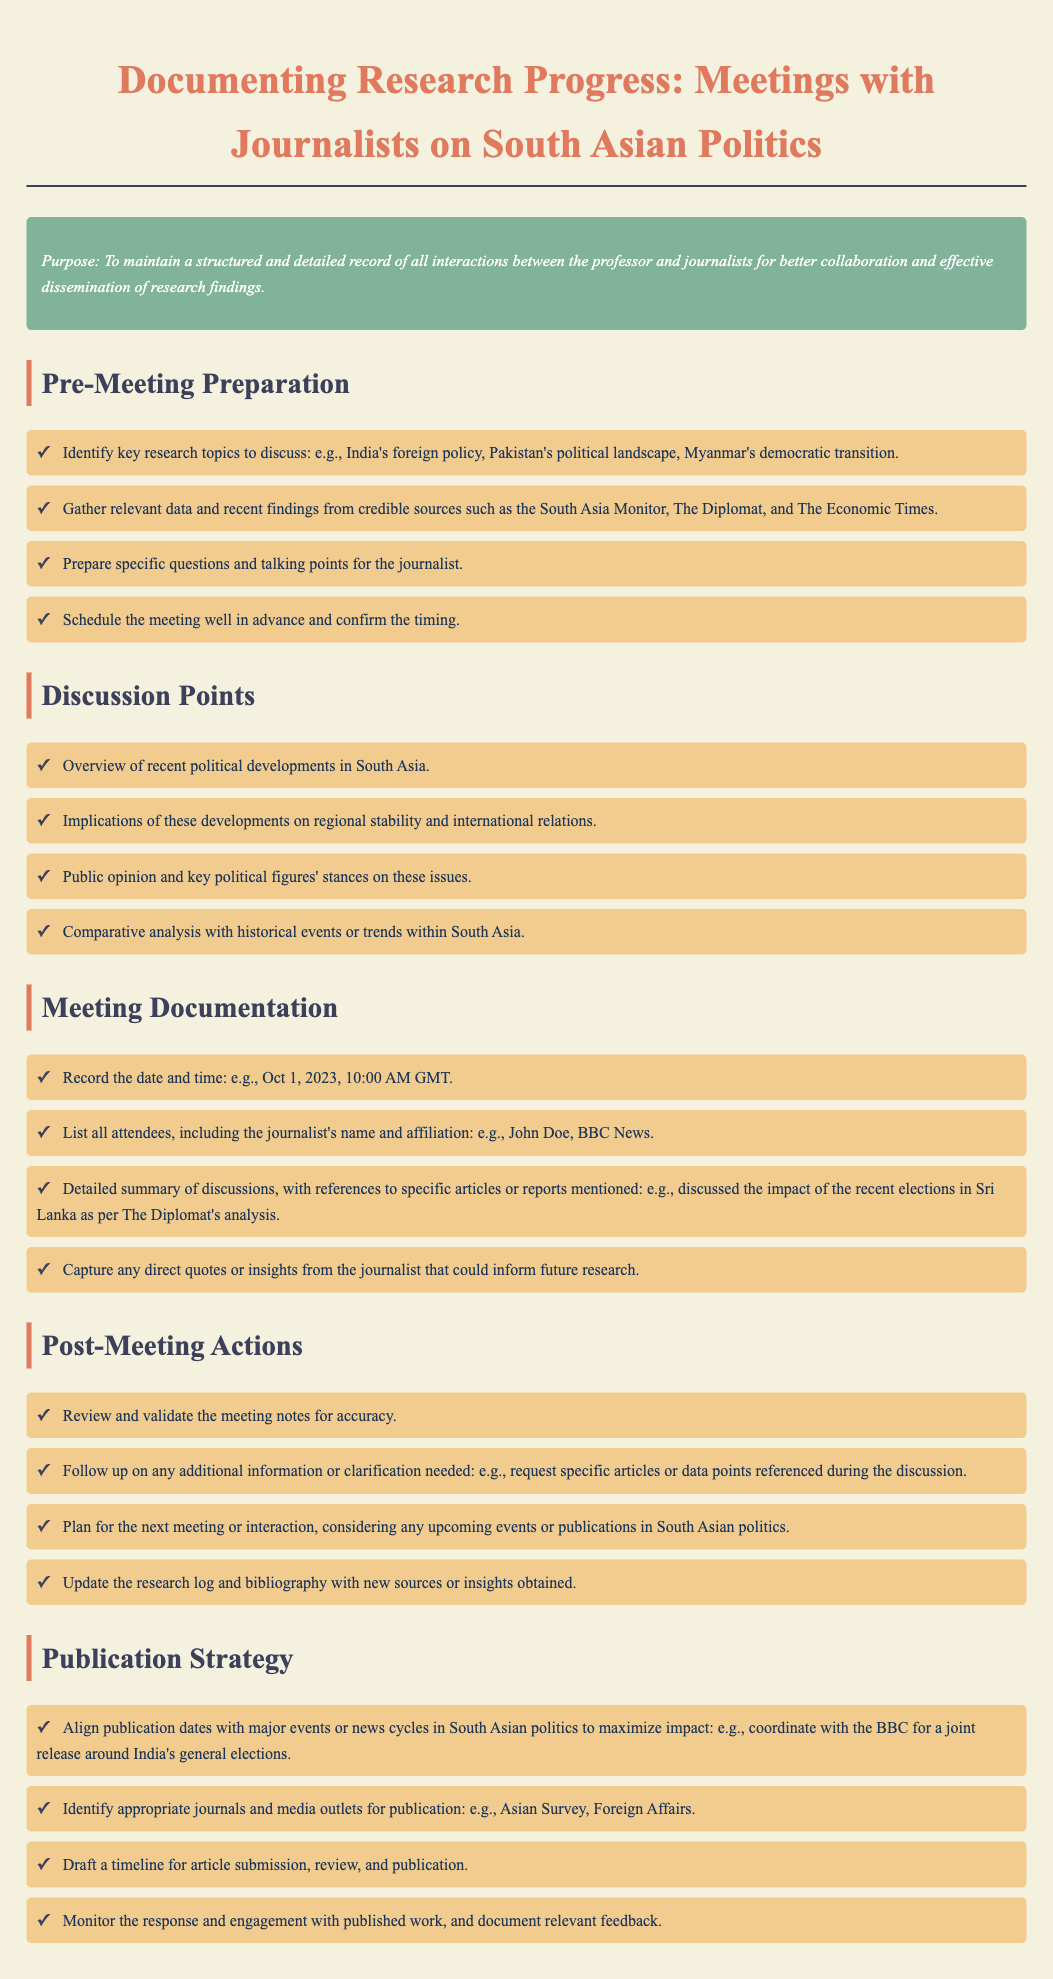what is the date of the meeting documented? The document mentions the date and time of a meeting as an example: Oct 1, 2023, 10:00 AM GMT.
Answer: Oct 1, 2023 who should be gathered in the meeting documentation? The document specifies to list all attendees, including the journalist's name and affiliation, like John Doe, BBC News.
Answer: John Doe, BBC News what is one of the pre-meeting preparation tasks? The document outlines the importance of identifying key research topics such as India's foreign policy and others.
Answer: Identify key research topics what was discussed regarding political developments? The document states that an overview of recent political developments in South Asia should be covered during discussions.
Answer: Overview of recent political developments what action should be taken after the meeting? The document advises to review and validate the meeting notes for accuracy as a post-meeting action.
Answer: Review and validate meeting notes which journal is mentioned as an appropriate publication outlet? The document lists suitable journals for publication, including Asian Survey and others.
Answer: Asian Survey what type of information should be followed up after meetings? The document highlights the need to follow up on any additional information or clarification needed from the discussions.
Answer: Additional information or clarification what should be documented in the publication strategy? A key aspect mentioned is to align publication dates with major events or news cycles in South Asian politics.
Answer: Align publication dates with major events 